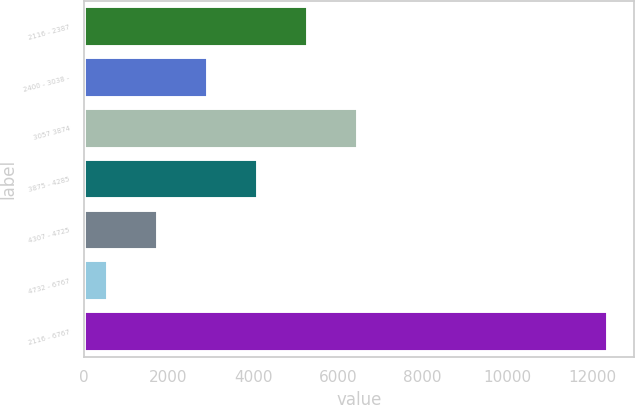Convert chart to OTSL. <chart><loc_0><loc_0><loc_500><loc_500><bar_chart><fcel>2116 - 2387<fcel>2400 - 3038 -<fcel>3057 3874<fcel>3875 - 4285<fcel>4307 - 4725<fcel>4732 - 6767<fcel>2116 - 6767<nl><fcel>5295.4<fcel>2933.2<fcel>6476.5<fcel>4114.3<fcel>1752.1<fcel>571<fcel>12382<nl></chart> 